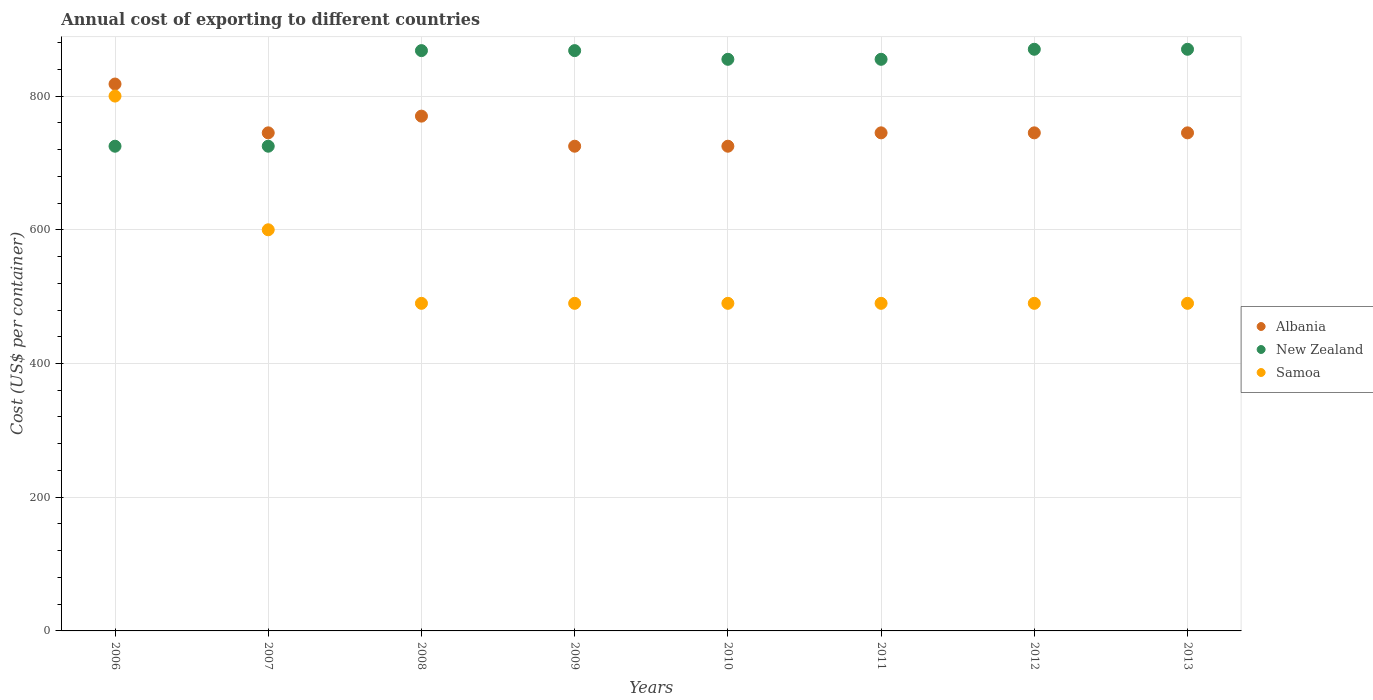How many different coloured dotlines are there?
Your answer should be compact. 3. Is the number of dotlines equal to the number of legend labels?
Provide a short and direct response. Yes. What is the total annual cost of exporting in Samoa in 2008?
Offer a very short reply. 490. Across all years, what is the maximum total annual cost of exporting in Albania?
Ensure brevity in your answer.  818. Across all years, what is the minimum total annual cost of exporting in Albania?
Provide a succinct answer. 725. What is the total total annual cost of exporting in New Zealand in the graph?
Provide a succinct answer. 6636. What is the difference between the total annual cost of exporting in Albania in 2006 and that in 2008?
Give a very brief answer. 48. What is the difference between the total annual cost of exporting in New Zealand in 2011 and the total annual cost of exporting in Albania in 2009?
Offer a very short reply. 130. What is the average total annual cost of exporting in New Zealand per year?
Make the answer very short. 829.5. In the year 2007, what is the difference between the total annual cost of exporting in Albania and total annual cost of exporting in Samoa?
Offer a very short reply. 145. What is the ratio of the total annual cost of exporting in Samoa in 2007 to that in 2008?
Offer a very short reply. 1.22. What is the difference between the highest and the second highest total annual cost of exporting in Samoa?
Your answer should be compact. 200. What is the difference between the highest and the lowest total annual cost of exporting in Albania?
Ensure brevity in your answer.  93. Is the sum of the total annual cost of exporting in Albania in 2008 and 2009 greater than the maximum total annual cost of exporting in New Zealand across all years?
Ensure brevity in your answer.  Yes. Is it the case that in every year, the sum of the total annual cost of exporting in New Zealand and total annual cost of exporting in Samoa  is greater than the total annual cost of exporting in Albania?
Make the answer very short. Yes. How many dotlines are there?
Offer a very short reply. 3. What is the difference between two consecutive major ticks on the Y-axis?
Your answer should be compact. 200. Are the values on the major ticks of Y-axis written in scientific E-notation?
Provide a short and direct response. No. Does the graph contain any zero values?
Your answer should be very brief. No. Does the graph contain grids?
Provide a short and direct response. Yes. How many legend labels are there?
Provide a succinct answer. 3. What is the title of the graph?
Offer a terse response. Annual cost of exporting to different countries. What is the label or title of the Y-axis?
Offer a terse response. Cost (US$ per container). What is the Cost (US$ per container) of Albania in 2006?
Keep it short and to the point. 818. What is the Cost (US$ per container) in New Zealand in 2006?
Offer a very short reply. 725. What is the Cost (US$ per container) in Samoa in 2006?
Your answer should be very brief. 800. What is the Cost (US$ per container) in Albania in 2007?
Your answer should be very brief. 745. What is the Cost (US$ per container) of New Zealand in 2007?
Make the answer very short. 725. What is the Cost (US$ per container) in Samoa in 2007?
Your response must be concise. 600. What is the Cost (US$ per container) in Albania in 2008?
Offer a very short reply. 770. What is the Cost (US$ per container) in New Zealand in 2008?
Offer a very short reply. 868. What is the Cost (US$ per container) of Samoa in 2008?
Make the answer very short. 490. What is the Cost (US$ per container) of Albania in 2009?
Keep it short and to the point. 725. What is the Cost (US$ per container) of New Zealand in 2009?
Your answer should be very brief. 868. What is the Cost (US$ per container) in Samoa in 2009?
Your answer should be very brief. 490. What is the Cost (US$ per container) of Albania in 2010?
Ensure brevity in your answer.  725. What is the Cost (US$ per container) in New Zealand in 2010?
Provide a short and direct response. 855. What is the Cost (US$ per container) of Samoa in 2010?
Give a very brief answer. 490. What is the Cost (US$ per container) of Albania in 2011?
Make the answer very short. 745. What is the Cost (US$ per container) of New Zealand in 2011?
Keep it short and to the point. 855. What is the Cost (US$ per container) of Samoa in 2011?
Make the answer very short. 490. What is the Cost (US$ per container) in Albania in 2012?
Keep it short and to the point. 745. What is the Cost (US$ per container) in New Zealand in 2012?
Keep it short and to the point. 870. What is the Cost (US$ per container) in Samoa in 2012?
Offer a terse response. 490. What is the Cost (US$ per container) in Albania in 2013?
Offer a terse response. 745. What is the Cost (US$ per container) of New Zealand in 2013?
Provide a succinct answer. 870. What is the Cost (US$ per container) in Samoa in 2013?
Provide a short and direct response. 490. Across all years, what is the maximum Cost (US$ per container) in Albania?
Offer a terse response. 818. Across all years, what is the maximum Cost (US$ per container) in New Zealand?
Provide a succinct answer. 870. Across all years, what is the maximum Cost (US$ per container) in Samoa?
Your answer should be very brief. 800. Across all years, what is the minimum Cost (US$ per container) of Albania?
Your answer should be compact. 725. Across all years, what is the minimum Cost (US$ per container) in New Zealand?
Offer a terse response. 725. Across all years, what is the minimum Cost (US$ per container) in Samoa?
Your response must be concise. 490. What is the total Cost (US$ per container) of Albania in the graph?
Offer a very short reply. 6018. What is the total Cost (US$ per container) of New Zealand in the graph?
Keep it short and to the point. 6636. What is the total Cost (US$ per container) in Samoa in the graph?
Offer a terse response. 4340. What is the difference between the Cost (US$ per container) of Albania in 2006 and that in 2007?
Offer a very short reply. 73. What is the difference between the Cost (US$ per container) in New Zealand in 2006 and that in 2007?
Ensure brevity in your answer.  0. What is the difference between the Cost (US$ per container) of Albania in 2006 and that in 2008?
Provide a short and direct response. 48. What is the difference between the Cost (US$ per container) of New Zealand in 2006 and that in 2008?
Your response must be concise. -143. What is the difference between the Cost (US$ per container) of Samoa in 2006 and that in 2008?
Make the answer very short. 310. What is the difference between the Cost (US$ per container) in Albania in 2006 and that in 2009?
Give a very brief answer. 93. What is the difference between the Cost (US$ per container) in New Zealand in 2006 and that in 2009?
Offer a very short reply. -143. What is the difference between the Cost (US$ per container) in Samoa in 2006 and that in 2009?
Offer a very short reply. 310. What is the difference between the Cost (US$ per container) of Albania in 2006 and that in 2010?
Keep it short and to the point. 93. What is the difference between the Cost (US$ per container) in New Zealand in 2006 and that in 2010?
Keep it short and to the point. -130. What is the difference between the Cost (US$ per container) of Samoa in 2006 and that in 2010?
Your answer should be very brief. 310. What is the difference between the Cost (US$ per container) of Albania in 2006 and that in 2011?
Offer a terse response. 73. What is the difference between the Cost (US$ per container) of New Zealand in 2006 and that in 2011?
Ensure brevity in your answer.  -130. What is the difference between the Cost (US$ per container) in Samoa in 2006 and that in 2011?
Ensure brevity in your answer.  310. What is the difference between the Cost (US$ per container) of New Zealand in 2006 and that in 2012?
Your response must be concise. -145. What is the difference between the Cost (US$ per container) of Samoa in 2006 and that in 2012?
Keep it short and to the point. 310. What is the difference between the Cost (US$ per container) in New Zealand in 2006 and that in 2013?
Your response must be concise. -145. What is the difference between the Cost (US$ per container) of Samoa in 2006 and that in 2013?
Make the answer very short. 310. What is the difference between the Cost (US$ per container) of New Zealand in 2007 and that in 2008?
Offer a terse response. -143. What is the difference between the Cost (US$ per container) in Samoa in 2007 and that in 2008?
Give a very brief answer. 110. What is the difference between the Cost (US$ per container) of New Zealand in 2007 and that in 2009?
Ensure brevity in your answer.  -143. What is the difference between the Cost (US$ per container) of Samoa in 2007 and that in 2009?
Offer a terse response. 110. What is the difference between the Cost (US$ per container) in Albania in 2007 and that in 2010?
Offer a very short reply. 20. What is the difference between the Cost (US$ per container) in New Zealand in 2007 and that in 2010?
Make the answer very short. -130. What is the difference between the Cost (US$ per container) of Samoa in 2007 and that in 2010?
Ensure brevity in your answer.  110. What is the difference between the Cost (US$ per container) of New Zealand in 2007 and that in 2011?
Make the answer very short. -130. What is the difference between the Cost (US$ per container) in Samoa in 2007 and that in 2011?
Make the answer very short. 110. What is the difference between the Cost (US$ per container) in New Zealand in 2007 and that in 2012?
Give a very brief answer. -145. What is the difference between the Cost (US$ per container) of Samoa in 2007 and that in 2012?
Your answer should be very brief. 110. What is the difference between the Cost (US$ per container) of Albania in 2007 and that in 2013?
Give a very brief answer. 0. What is the difference between the Cost (US$ per container) in New Zealand in 2007 and that in 2013?
Provide a short and direct response. -145. What is the difference between the Cost (US$ per container) in Samoa in 2007 and that in 2013?
Your answer should be very brief. 110. What is the difference between the Cost (US$ per container) of New Zealand in 2008 and that in 2009?
Offer a terse response. 0. What is the difference between the Cost (US$ per container) of Samoa in 2008 and that in 2009?
Your response must be concise. 0. What is the difference between the Cost (US$ per container) in Samoa in 2008 and that in 2010?
Give a very brief answer. 0. What is the difference between the Cost (US$ per container) of Albania in 2008 and that in 2011?
Offer a very short reply. 25. What is the difference between the Cost (US$ per container) in New Zealand in 2008 and that in 2011?
Provide a short and direct response. 13. What is the difference between the Cost (US$ per container) of Albania in 2008 and that in 2012?
Your answer should be compact. 25. What is the difference between the Cost (US$ per container) in New Zealand in 2008 and that in 2012?
Provide a succinct answer. -2. What is the difference between the Cost (US$ per container) of Samoa in 2008 and that in 2012?
Ensure brevity in your answer.  0. What is the difference between the Cost (US$ per container) of New Zealand in 2008 and that in 2013?
Offer a terse response. -2. What is the difference between the Cost (US$ per container) of Albania in 2009 and that in 2010?
Offer a very short reply. 0. What is the difference between the Cost (US$ per container) of Samoa in 2009 and that in 2010?
Provide a short and direct response. 0. What is the difference between the Cost (US$ per container) in New Zealand in 2009 and that in 2011?
Keep it short and to the point. 13. What is the difference between the Cost (US$ per container) of Samoa in 2009 and that in 2011?
Keep it short and to the point. 0. What is the difference between the Cost (US$ per container) of Albania in 2009 and that in 2012?
Ensure brevity in your answer.  -20. What is the difference between the Cost (US$ per container) of New Zealand in 2009 and that in 2012?
Offer a very short reply. -2. What is the difference between the Cost (US$ per container) in Samoa in 2009 and that in 2012?
Make the answer very short. 0. What is the difference between the Cost (US$ per container) in Albania in 2009 and that in 2013?
Provide a succinct answer. -20. What is the difference between the Cost (US$ per container) in New Zealand in 2009 and that in 2013?
Provide a short and direct response. -2. What is the difference between the Cost (US$ per container) of Samoa in 2009 and that in 2013?
Provide a succinct answer. 0. What is the difference between the Cost (US$ per container) of Albania in 2010 and that in 2011?
Make the answer very short. -20. What is the difference between the Cost (US$ per container) of New Zealand in 2010 and that in 2011?
Offer a very short reply. 0. What is the difference between the Cost (US$ per container) in Samoa in 2010 and that in 2012?
Make the answer very short. 0. What is the difference between the Cost (US$ per container) in Albania in 2010 and that in 2013?
Provide a short and direct response. -20. What is the difference between the Cost (US$ per container) of New Zealand in 2011 and that in 2012?
Ensure brevity in your answer.  -15. What is the difference between the Cost (US$ per container) in Samoa in 2011 and that in 2012?
Keep it short and to the point. 0. What is the difference between the Cost (US$ per container) in New Zealand in 2011 and that in 2013?
Keep it short and to the point. -15. What is the difference between the Cost (US$ per container) in Samoa in 2011 and that in 2013?
Offer a very short reply. 0. What is the difference between the Cost (US$ per container) in New Zealand in 2012 and that in 2013?
Give a very brief answer. 0. What is the difference between the Cost (US$ per container) of Albania in 2006 and the Cost (US$ per container) of New Zealand in 2007?
Provide a succinct answer. 93. What is the difference between the Cost (US$ per container) of Albania in 2006 and the Cost (US$ per container) of Samoa in 2007?
Your response must be concise. 218. What is the difference between the Cost (US$ per container) of New Zealand in 2006 and the Cost (US$ per container) of Samoa in 2007?
Make the answer very short. 125. What is the difference between the Cost (US$ per container) in Albania in 2006 and the Cost (US$ per container) in Samoa in 2008?
Offer a terse response. 328. What is the difference between the Cost (US$ per container) of New Zealand in 2006 and the Cost (US$ per container) of Samoa in 2008?
Give a very brief answer. 235. What is the difference between the Cost (US$ per container) in Albania in 2006 and the Cost (US$ per container) in New Zealand in 2009?
Your answer should be very brief. -50. What is the difference between the Cost (US$ per container) of Albania in 2006 and the Cost (US$ per container) of Samoa in 2009?
Your answer should be very brief. 328. What is the difference between the Cost (US$ per container) of New Zealand in 2006 and the Cost (US$ per container) of Samoa in 2009?
Give a very brief answer. 235. What is the difference between the Cost (US$ per container) of Albania in 2006 and the Cost (US$ per container) of New Zealand in 2010?
Provide a succinct answer. -37. What is the difference between the Cost (US$ per container) of Albania in 2006 and the Cost (US$ per container) of Samoa in 2010?
Your response must be concise. 328. What is the difference between the Cost (US$ per container) of New Zealand in 2006 and the Cost (US$ per container) of Samoa in 2010?
Keep it short and to the point. 235. What is the difference between the Cost (US$ per container) in Albania in 2006 and the Cost (US$ per container) in New Zealand in 2011?
Offer a very short reply. -37. What is the difference between the Cost (US$ per container) of Albania in 2006 and the Cost (US$ per container) of Samoa in 2011?
Provide a short and direct response. 328. What is the difference between the Cost (US$ per container) of New Zealand in 2006 and the Cost (US$ per container) of Samoa in 2011?
Offer a very short reply. 235. What is the difference between the Cost (US$ per container) in Albania in 2006 and the Cost (US$ per container) in New Zealand in 2012?
Keep it short and to the point. -52. What is the difference between the Cost (US$ per container) in Albania in 2006 and the Cost (US$ per container) in Samoa in 2012?
Your response must be concise. 328. What is the difference between the Cost (US$ per container) of New Zealand in 2006 and the Cost (US$ per container) of Samoa in 2012?
Offer a very short reply. 235. What is the difference between the Cost (US$ per container) of Albania in 2006 and the Cost (US$ per container) of New Zealand in 2013?
Keep it short and to the point. -52. What is the difference between the Cost (US$ per container) in Albania in 2006 and the Cost (US$ per container) in Samoa in 2013?
Your answer should be very brief. 328. What is the difference between the Cost (US$ per container) in New Zealand in 2006 and the Cost (US$ per container) in Samoa in 2013?
Keep it short and to the point. 235. What is the difference between the Cost (US$ per container) of Albania in 2007 and the Cost (US$ per container) of New Zealand in 2008?
Your answer should be very brief. -123. What is the difference between the Cost (US$ per container) of Albania in 2007 and the Cost (US$ per container) of Samoa in 2008?
Your response must be concise. 255. What is the difference between the Cost (US$ per container) of New Zealand in 2007 and the Cost (US$ per container) of Samoa in 2008?
Offer a terse response. 235. What is the difference between the Cost (US$ per container) in Albania in 2007 and the Cost (US$ per container) in New Zealand in 2009?
Your answer should be compact. -123. What is the difference between the Cost (US$ per container) of Albania in 2007 and the Cost (US$ per container) of Samoa in 2009?
Your response must be concise. 255. What is the difference between the Cost (US$ per container) in New Zealand in 2007 and the Cost (US$ per container) in Samoa in 2009?
Offer a very short reply. 235. What is the difference between the Cost (US$ per container) of Albania in 2007 and the Cost (US$ per container) of New Zealand in 2010?
Your answer should be compact. -110. What is the difference between the Cost (US$ per container) of Albania in 2007 and the Cost (US$ per container) of Samoa in 2010?
Provide a short and direct response. 255. What is the difference between the Cost (US$ per container) of New Zealand in 2007 and the Cost (US$ per container) of Samoa in 2010?
Your response must be concise. 235. What is the difference between the Cost (US$ per container) of Albania in 2007 and the Cost (US$ per container) of New Zealand in 2011?
Ensure brevity in your answer.  -110. What is the difference between the Cost (US$ per container) in Albania in 2007 and the Cost (US$ per container) in Samoa in 2011?
Give a very brief answer. 255. What is the difference between the Cost (US$ per container) of New Zealand in 2007 and the Cost (US$ per container) of Samoa in 2011?
Ensure brevity in your answer.  235. What is the difference between the Cost (US$ per container) in Albania in 2007 and the Cost (US$ per container) in New Zealand in 2012?
Your response must be concise. -125. What is the difference between the Cost (US$ per container) in Albania in 2007 and the Cost (US$ per container) in Samoa in 2012?
Make the answer very short. 255. What is the difference between the Cost (US$ per container) in New Zealand in 2007 and the Cost (US$ per container) in Samoa in 2012?
Provide a succinct answer. 235. What is the difference between the Cost (US$ per container) of Albania in 2007 and the Cost (US$ per container) of New Zealand in 2013?
Make the answer very short. -125. What is the difference between the Cost (US$ per container) in Albania in 2007 and the Cost (US$ per container) in Samoa in 2013?
Provide a succinct answer. 255. What is the difference between the Cost (US$ per container) in New Zealand in 2007 and the Cost (US$ per container) in Samoa in 2013?
Your answer should be very brief. 235. What is the difference between the Cost (US$ per container) in Albania in 2008 and the Cost (US$ per container) in New Zealand in 2009?
Your answer should be compact. -98. What is the difference between the Cost (US$ per container) in Albania in 2008 and the Cost (US$ per container) in Samoa in 2009?
Keep it short and to the point. 280. What is the difference between the Cost (US$ per container) in New Zealand in 2008 and the Cost (US$ per container) in Samoa in 2009?
Make the answer very short. 378. What is the difference between the Cost (US$ per container) of Albania in 2008 and the Cost (US$ per container) of New Zealand in 2010?
Keep it short and to the point. -85. What is the difference between the Cost (US$ per container) in Albania in 2008 and the Cost (US$ per container) in Samoa in 2010?
Your response must be concise. 280. What is the difference between the Cost (US$ per container) in New Zealand in 2008 and the Cost (US$ per container) in Samoa in 2010?
Provide a short and direct response. 378. What is the difference between the Cost (US$ per container) in Albania in 2008 and the Cost (US$ per container) in New Zealand in 2011?
Offer a terse response. -85. What is the difference between the Cost (US$ per container) in Albania in 2008 and the Cost (US$ per container) in Samoa in 2011?
Keep it short and to the point. 280. What is the difference between the Cost (US$ per container) of New Zealand in 2008 and the Cost (US$ per container) of Samoa in 2011?
Provide a succinct answer. 378. What is the difference between the Cost (US$ per container) of Albania in 2008 and the Cost (US$ per container) of New Zealand in 2012?
Make the answer very short. -100. What is the difference between the Cost (US$ per container) of Albania in 2008 and the Cost (US$ per container) of Samoa in 2012?
Offer a terse response. 280. What is the difference between the Cost (US$ per container) of New Zealand in 2008 and the Cost (US$ per container) of Samoa in 2012?
Your answer should be compact. 378. What is the difference between the Cost (US$ per container) of Albania in 2008 and the Cost (US$ per container) of New Zealand in 2013?
Keep it short and to the point. -100. What is the difference between the Cost (US$ per container) of Albania in 2008 and the Cost (US$ per container) of Samoa in 2013?
Your answer should be compact. 280. What is the difference between the Cost (US$ per container) of New Zealand in 2008 and the Cost (US$ per container) of Samoa in 2013?
Offer a terse response. 378. What is the difference between the Cost (US$ per container) of Albania in 2009 and the Cost (US$ per container) of New Zealand in 2010?
Your answer should be compact. -130. What is the difference between the Cost (US$ per container) in Albania in 2009 and the Cost (US$ per container) in Samoa in 2010?
Provide a short and direct response. 235. What is the difference between the Cost (US$ per container) of New Zealand in 2009 and the Cost (US$ per container) of Samoa in 2010?
Make the answer very short. 378. What is the difference between the Cost (US$ per container) of Albania in 2009 and the Cost (US$ per container) of New Zealand in 2011?
Ensure brevity in your answer.  -130. What is the difference between the Cost (US$ per container) of Albania in 2009 and the Cost (US$ per container) of Samoa in 2011?
Provide a short and direct response. 235. What is the difference between the Cost (US$ per container) in New Zealand in 2009 and the Cost (US$ per container) in Samoa in 2011?
Provide a succinct answer. 378. What is the difference between the Cost (US$ per container) of Albania in 2009 and the Cost (US$ per container) of New Zealand in 2012?
Offer a very short reply. -145. What is the difference between the Cost (US$ per container) of Albania in 2009 and the Cost (US$ per container) of Samoa in 2012?
Keep it short and to the point. 235. What is the difference between the Cost (US$ per container) in New Zealand in 2009 and the Cost (US$ per container) in Samoa in 2012?
Offer a terse response. 378. What is the difference between the Cost (US$ per container) of Albania in 2009 and the Cost (US$ per container) of New Zealand in 2013?
Your answer should be compact. -145. What is the difference between the Cost (US$ per container) in Albania in 2009 and the Cost (US$ per container) in Samoa in 2013?
Offer a very short reply. 235. What is the difference between the Cost (US$ per container) of New Zealand in 2009 and the Cost (US$ per container) of Samoa in 2013?
Your answer should be compact. 378. What is the difference between the Cost (US$ per container) in Albania in 2010 and the Cost (US$ per container) in New Zealand in 2011?
Keep it short and to the point. -130. What is the difference between the Cost (US$ per container) of Albania in 2010 and the Cost (US$ per container) of Samoa in 2011?
Offer a very short reply. 235. What is the difference between the Cost (US$ per container) in New Zealand in 2010 and the Cost (US$ per container) in Samoa in 2011?
Ensure brevity in your answer.  365. What is the difference between the Cost (US$ per container) in Albania in 2010 and the Cost (US$ per container) in New Zealand in 2012?
Your answer should be very brief. -145. What is the difference between the Cost (US$ per container) of Albania in 2010 and the Cost (US$ per container) of Samoa in 2012?
Provide a succinct answer. 235. What is the difference between the Cost (US$ per container) in New Zealand in 2010 and the Cost (US$ per container) in Samoa in 2012?
Your answer should be very brief. 365. What is the difference between the Cost (US$ per container) of Albania in 2010 and the Cost (US$ per container) of New Zealand in 2013?
Offer a very short reply. -145. What is the difference between the Cost (US$ per container) in Albania in 2010 and the Cost (US$ per container) in Samoa in 2013?
Offer a very short reply. 235. What is the difference between the Cost (US$ per container) of New Zealand in 2010 and the Cost (US$ per container) of Samoa in 2013?
Give a very brief answer. 365. What is the difference between the Cost (US$ per container) of Albania in 2011 and the Cost (US$ per container) of New Zealand in 2012?
Provide a short and direct response. -125. What is the difference between the Cost (US$ per container) in Albania in 2011 and the Cost (US$ per container) in Samoa in 2012?
Keep it short and to the point. 255. What is the difference between the Cost (US$ per container) in New Zealand in 2011 and the Cost (US$ per container) in Samoa in 2012?
Keep it short and to the point. 365. What is the difference between the Cost (US$ per container) in Albania in 2011 and the Cost (US$ per container) in New Zealand in 2013?
Give a very brief answer. -125. What is the difference between the Cost (US$ per container) in Albania in 2011 and the Cost (US$ per container) in Samoa in 2013?
Give a very brief answer. 255. What is the difference between the Cost (US$ per container) of New Zealand in 2011 and the Cost (US$ per container) of Samoa in 2013?
Ensure brevity in your answer.  365. What is the difference between the Cost (US$ per container) in Albania in 2012 and the Cost (US$ per container) in New Zealand in 2013?
Ensure brevity in your answer.  -125. What is the difference between the Cost (US$ per container) in Albania in 2012 and the Cost (US$ per container) in Samoa in 2013?
Give a very brief answer. 255. What is the difference between the Cost (US$ per container) in New Zealand in 2012 and the Cost (US$ per container) in Samoa in 2013?
Ensure brevity in your answer.  380. What is the average Cost (US$ per container) of Albania per year?
Offer a terse response. 752.25. What is the average Cost (US$ per container) of New Zealand per year?
Keep it short and to the point. 829.5. What is the average Cost (US$ per container) of Samoa per year?
Ensure brevity in your answer.  542.5. In the year 2006, what is the difference between the Cost (US$ per container) in Albania and Cost (US$ per container) in New Zealand?
Your answer should be compact. 93. In the year 2006, what is the difference between the Cost (US$ per container) of Albania and Cost (US$ per container) of Samoa?
Keep it short and to the point. 18. In the year 2006, what is the difference between the Cost (US$ per container) of New Zealand and Cost (US$ per container) of Samoa?
Your answer should be compact. -75. In the year 2007, what is the difference between the Cost (US$ per container) of Albania and Cost (US$ per container) of New Zealand?
Give a very brief answer. 20. In the year 2007, what is the difference between the Cost (US$ per container) of Albania and Cost (US$ per container) of Samoa?
Your response must be concise. 145. In the year 2007, what is the difference between the Cost (US$ per container) of New Zealand and Cost (US$ per container) of Samoa?
Give a very brief answer. 125. In the year 2008, what is the difference between the Cost (US$ per container) of Albania and Cost (US$ per container) of New Zealand?
Your answer should be compact. -98. In the year 2008, what is the difference between the Cost (US$ per container) in Albania and Cost (US$ per container) in Samoa?
Your answer should be compact. 280. In the year 2008, what is the difference between the Cost (US$ per container) of New Zealand and Cost (US$ per container) of Samoa?
Your response must be concise. 378. In the year 2009, what is the difference between the Cost (US$ per container) in Albania and Cost (US$ per container) in New Zealand?
Offer a terse response. -143. In the year 2009, what is the difference between the Cost (US$ per container) of Albania and Cost (US$ per container) of Samoa?
Offer a very short reply. 235. In the year 2009, what is the difference between the Cost (US$ per container) of New Zealand and Cost (US$ per container) of Samoa?
Keep it short and to the point. 378. In the year 2010, what is the difference between the Cost (US$ per container) in Albania and Cost (US$ per container) in New Zealand?
Your response must be concise. -130. In the year 2010, what is the difference between the Cost (US$ per container) of Albania and Cost (US$ per container) of Samoa?
Offer a very short reply. 235. In the year 2010, what is the difference between the Cost (US$ per container) in New Zealand and Cost (US$ per container) in Samoa?
Your response must be concise. 365. In the year 2011, what is the difference between the Cost (US$ per container) of Albania and Cost (US$ per container) of New Zealand?
Your response must be concise. -110. In the year 2011, what is the difference between the Cost (US$ per container) in Albania and Cost (US$ per container) in Samoa?
Your response must be concise. 255. In the year 2011, what is the difference between the Cost (US$ per container) of New Zealand and Cost (US$ per container) of Samoa?
Give a very brief answer. 365. In the year 2012, what is the difference between the Cost (US$ per container) of Albania and Cost (US$ per container) of New Zealand?
Offer a very short reply. -125. In the year 2012, what is the difference between the Cost (US$ per container) of Albania and Cost (US$ per container) of Samoa?
Provide a short and direct response. 255. In the year 2012, what is the difference between the Cost (US$ per container) of New Zealand and Cost (US$ per container) of Samoa?
Ensure brevity in your answer.  380. In the year 2013, what is the difference between the Cost (US$ per container) in Albania and Cost (US$ per container) in New Zealand?
Provide a short and direct response. -125. In the year 2013, what is the difference between the Cost (US$ per container) in Albania and Cost (US$ per container) in Samoa?
Your answer should be very brief. 255. In the year 2013, what is the difference between the Cost (US$ per container) of New Zealand and Cost (US$ per container) of Samoa?
Offer a terse response. 380. What is the ratio of the Cost (US$ per container) of Albania in 2006 to that in 2007?
Make the answer very short. 1.1. What is the ratio of the Cost (US$ per container) in Samoa in 2006 to that in 2007?
Provide a short and direct response. 1.33. What is the ratio of the Cost (US$ per container) of Albania in 2006 to that in 2008?
Ensure brevity in your answer.  1.06. What is the ratio of the Cost (US$ per container) in New Zealand in 2006 to that in 2008?
Ensure brevity in your answer.  0.84. What is the ratio of the Cost (US$ per container) of Samoa in 2006 to that in 2008?
Ensure brevity in your answer.  1.63. What is the ratio of the Cost (US$ per container) of Albania in 2006 to that in 2009?
Ensure brevity in your answer.  1.13. What is the ratio of the Cost (US$ per container) of New Zealand in 2006 to that in 2009?
Your answer should be compact. 0.84. What is the ratio of the Cost (US$ per container) in Samoa in 2006 to that in 2009?
Make the answer very short. 1.63. What is the ratio of the Cost (US$ per container) of Albania in 2006 to that in 2010?
Offer a very short reply. 1.13. What is the ratio of the Cost (US$ per container) of New Zealand in 2006 to that in 2010?
Keep it short and to the point. 0.85. What is the ratio of the Cost (US$ per container) of Samoa in 2006 to that in 2010?
Make the answer very short. 1.63. What is the ratio of the Cost (US$ per container) of Albania in 2006 to that in 2011?
Offer a terse response. 1.1. What is the ratio of the Cost (US$ per container) in New Zealand in 2006 to that in 2011?
Your response must be concise. 0.85. What is the ratio of the Cost (US$ per container) in Samoa in 2006 to that in 2011?
Provide a succinct answer. 1.63. What is the ratio of the Cost (US$ per container) in Albania in 2006 to that in 2012?
Provide a short and direct response. 1.1. What is the ratio of the Cost (US$ per container) of New Zealand in 2006 to that in 2012?
Provide a short and direct response. 0.83. What is the ratio of the Cost (US$ per container) of Samoa in 2006 to that in 2012?
Give a very brief answer. 1.63. What is the ratio of the Cost (US$ per container) of Albania in 2006 to that in 2013?
Offer a terse response. 1.1. What is the ratio of the Cost (US$ per container) of Samoa in 2006 to that in 2013?
Provide a short and direct response. 1.63. What is the ratio of the Cost (US$ per container) in Albania in 2007 to that in 2008?
Offer a terse response. 0.97. What is the ratio of the Cost (US$ per container) in New Zealand in 2007 to that in 2008?
Your response must be concise. 0.84. What is the ratio of the Cost (US$ per container) in Samoa in 2007 to that in 2008?
Your answer should be very brief. 1.22. What is the ratio of the Cost (US$ per container) in Albania in 2007 to that in 2009?
Keep it short and to the point. 1.03. What is the ratio of the Cost (US$ per container) in New Zealand in 2007 to that in 2009?
Your answer should be compact. 0.84. What is the ratio of the Cost (US$ per container) in Samoa in 2007 to that in 2009?
Give a very brief answer. 1.22. What is the ratio of the Cost (US$ per container) of Albania in 2007 to that in 2010?
Ensure brevity in your answer.  1.03. What is the ratio of the Cost (US$ per container) of New Zealand in 2007 to that in 2010?
Provide a short and direct response. 0.85. What is the ratio of the Cost (US$ per container) in Samoa in 2007 to that in 2010?
Provide a short and direct response. 1.22. What is the ratio of the Cost (US$ per container) of New Zealand in 2007 to that in 2011?
Keep it short and to the point. 0.85. What is the ratio of the Cost (US$ per container) in Samoa in 2007 to that in 2011?
Your answer should be compact. 1.22. What is the ratio of the Cost (US$ per container) in Albania in 2007 to that in 2012?
Give a very brief answer. 1. What is the ratio of the Cost (US$ per container) in New Zealand in 2007 to that in 2012?
Your answer should be compact. 0.83. What is the ratio of the Cost (US$ per container) in Samoa in 2007 to that in 2012?
Your response must be concise. 1.22. What is the ratio of the Cost (US$ per container) of New Zealand in 2007 to that in 2013?
Provide a succinct answer. 0.83. What is the ratio of the Cost (US$ per container) in Samoa in 2007 to that in 2013?
Your response must be concise. 1.22. What is the ratio of the Cost (US$ per container) in Albania in 2008 to that in 2009?
Offer a very short reply. 1.06. What is the ratio of the Cost (US$ per container) of New Zealand in 2008 to that in 2009?
Provide a short and direct response. 1. What is the ratio of the Cost (US$ per container) of Albania in 2008 to that in 2010?
Make the answer very short. 1.06. What is the ratio of the Cost (US$ per container) of New Zealand in 2008 to that in 2010?
Provide a succinct answer. 1.02. What is the ratio of the Cost (US$ per container) of Albania in 2008 to that in 2011?
Your response must be concise. 1.03. What is the ratio of the Cost (US$ per container) in New Zealand in 2008 to that in 2011?
Your response must be concise. 1.02. What is the ratio of the Cost (US$ per container) in Samoa in 2008 to that in 2011?
Keep it short and to the point. 1. What is the ratio of the Cost (US$ per container) of Albania in 2008 to that in 2012?
Provide a short and direct response. 1.03. What is the ratio of the Cost (US$ per container) of New Zealand in 2008 to that in 2012?
Offer a terse response. 1. What is the ratio of the Cost (US$ per container) in Albania in 2008 to that in 2013?
Offer a very short reply. 1.03. What is the ratio of the Cost (US$ per container) in New Zealand in 2008 to that in 2013?
Make the answer very short. 1. What is the ratio of the Cost (US$ per container) in Albania in 2009 to that in 2010?
Provide a succinct answer. 1. What is the ratio of the Cost (US$ per container) in New Zealand in 2009 to that in 2010?
Provide a short and direct response. 1.02. What is the ratio of the Cost (US$ per container) of Albania in 2009 to that in 2011?
Offer a very short reply. 0.97. What is the ratio of the Cost (US$ per container) of New Zealand in 2009 to that in 2011?
Offer a very short reply. 1.02. What is the ratio of the Cost (US$ per container) in Samoa in 2009 to that in 2011?
Give a very brief answer. 1. What is the ratio of the Cost (US$ per container) in Albania in 2009 to that in 2012?
Your answer should be compact. 0.97. What is the ratio of the Cost (US$ per container) of New Zealand in 2009 to that in 2012?
Offer a terse response. 1. What is the ratio of the Cost (US$ per container) of Albania in 2009 to that in 2013?
Make the answer very short. 0.97. What is the ratio of the Cost (US$ per container) of Albania in 2010 to that in 2011?
Offer a very short reply. 0.97. What is the ratio of the Cost (US$ per container) in Albania in 2010 to that in 2012?
Your answer should be very brief. 0.97. What is the ratio of the Cost (US$ per container) of New Zealand in 2010 to that in 2012?
Offer a terse response. 0.98. What is the ratio of the Cost (US$ per container) of Albania in 2010 to that in 2013?
Make the answer very short. 0.97. What is the ratio of the Cost (US$ per container) in New Zealand in 2010 to that in 2013?
Ensure brevity in your answer.  0.98. What is the ratio of the Cost (US$ per container) in Samoa in 2010 to that in 2013?
Ensure brevity in your answer.  1. What is the ratio of the Cost (US$ per container) of Albania in 2011 to that in 2012?
Offer a very short reply. 1. What is the ratio of the Cost (US$ per container) in New Zealand in 2011 to that in 2012?
Keep it short and to the point. 0.98. What is the ratio of the Cost (US$ per container) of New Zealand in 2011 to that in 2013?
Offer a terse response. 0.98. What is the ratio of the Cost (US$ per container) in Albania in 2012 to that in 2013?
Provide a short and direct response. 1. What is the ratio of the Cost (US$ per container) in Samoa in 2012 to that in 2013?
Ensure brevity in your answer.  1. What is the difference between the highest and the second highest Cost (US$ per container) of Samoa?
Ensure brevity in your answer.  200. What is the difference between the highest and the lowest Cost (US$ per container) of Albania?
Ensure brevity in your answer.  93. What is the difference between the highest and the lowest Cost (US$ per container) in New Zealand?
Give a very brief answer. 145. What is the difference between the highest and the lowest Cost (US$ per container) in Samoa?
Keep it short and to the point. 310. 